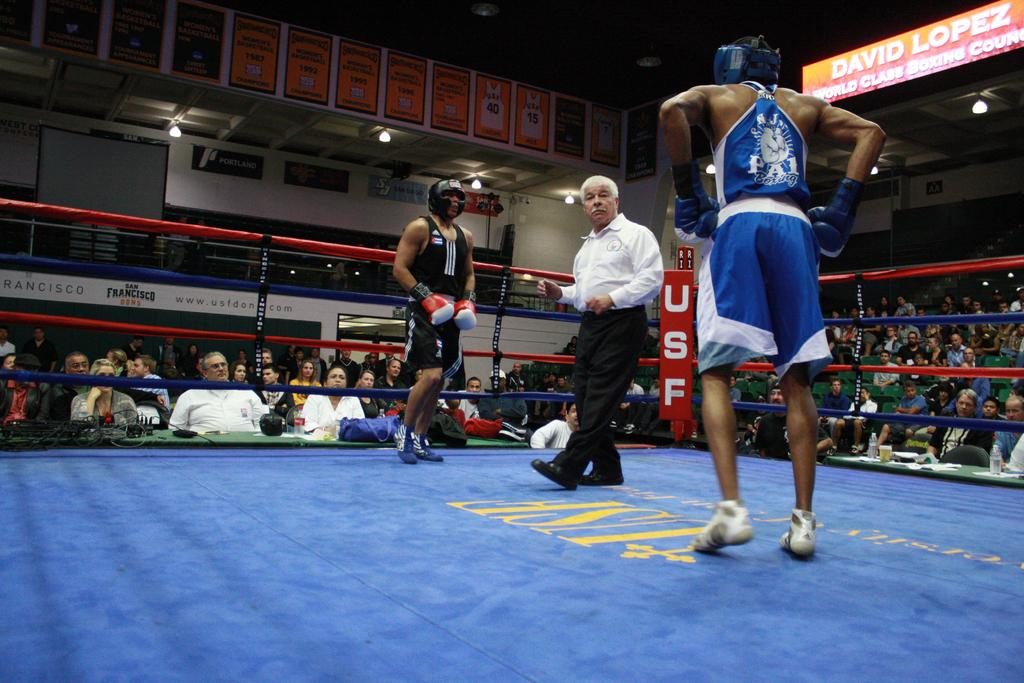<image>
Share a concise interpretation of the image provided. Two fighters and a referee in a USF sponsored boxing ring. 